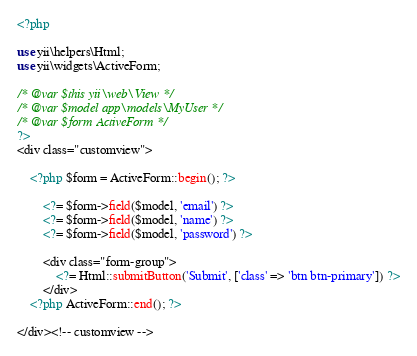<code> <loc_0><loc_0><loc_500><loc_500><_PHP_><?php

use yii\helpers\Html;
use yii\widgets\ActiveForm;

/* @var $this yii\web\View */
/* @var $model app\models\MyUser */
/* @var $form ActiveForm */
?>
<div class="customview">

    <?php $form = ActiveForm::begin(); ?>

        <?= $form->field($model, 'email') ?>
        <?= $form->field($model, 'name') ?>
        <?= $form->field($model, 'password') ?>
    
        <div class="form-group">
            <?= Html::submitButton('Submit', ['class' => 'btn btn-primary']) ?>
        </div>
    <?php ActiveForm::end(); ?>

</div><!-- customview -->
</code> 